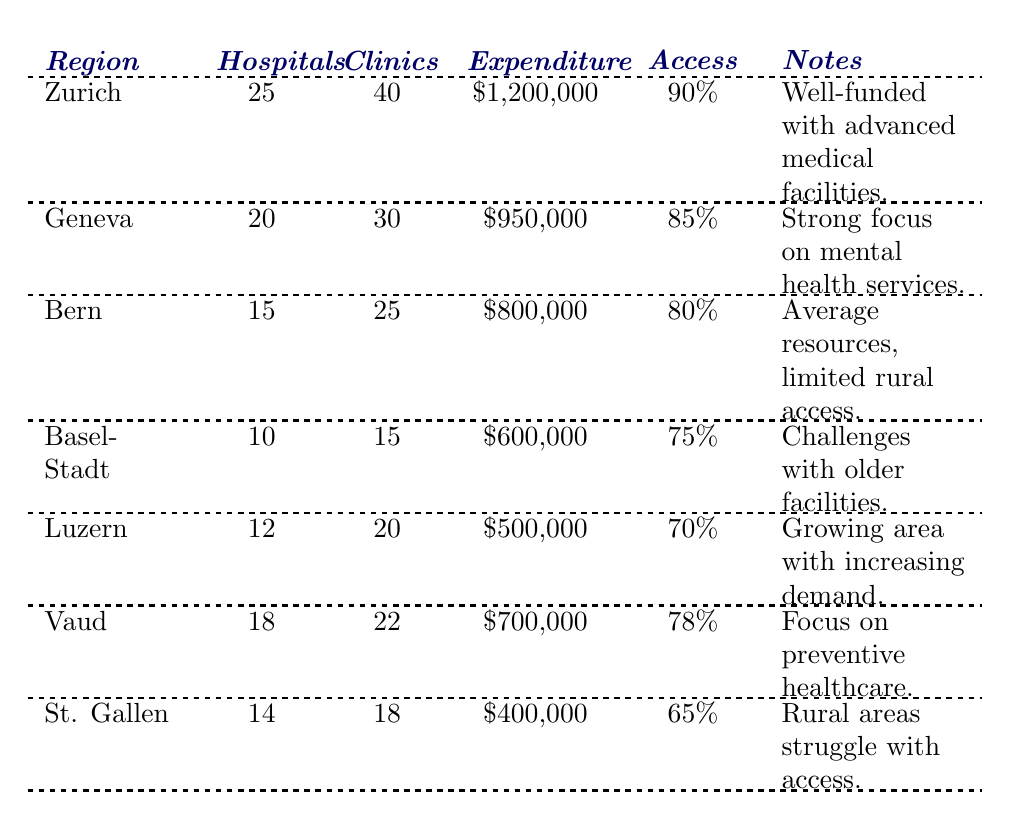What is the region with the highest public health expenditure? The expenditure for each region is listed in the table. Zurich has the highest expenditure at $1,200,000.
Answer: Zurich Which region has the lowest percentage of the population with access to health resources? By comparing the percentages, St. Gallen has the lowest access at 65%.
Answer: St. Gallen How many hospitals are there in Vaud? The table shows that Vaud has 18 hospitals listed.
Answer: 18 What is the total number of clinics across all regions? To find the total, sum the clinics: 40 + 30 + 25 + 15 + 20 + 22 + 18 = 170.
Answer: 170 Is the percentage of the population with access in Bern greater than that in Basel-Stadt? Bern has 80% access and Basel-Stadt has 75%, so Bern's percentage is greater.
Answer: Yes How many more hospitals does Zurich have than St. Gallen? Zurich has 25 hospitals and St. Gallen has 14, so the difference is 25 - 14 = 11.
Answer: 11 What is the average public health expenditure across all regions? The expenditures are $1,200,000, $950,000, $800,000, $600,000, $500,000, $700,000, and $400,000. Summing these gives $4,200,000. Dividing by the number of regions (7) yields an average of $4,200,000 / 7 = $600,000.
Answer: $600,000 How many clinics does Geneva have compared to Luzern? Geneva has 30 clinics, while Luzern has 20. The comparison shows that Geneva has 10 more clinics than Luzern.
Answer: 10 more Which region has a stronger focus on mental health services? The note for Geneva specifically states it has a strong focus on mental health services.
Answer: Geneva If Zurich's public health expenditure increases by $100,000, what will be its new total? Adding $100,000 to Zurich's current expenditure of $1,200,000 gives $1,200,000 + $100,000 = $1,300,000.
Answer: $1,300,000 